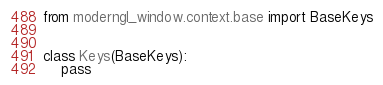<code> <loc_0><loc_0><loc_500><loc_500><_Python_>from moderngl_window.context.base import BaseKeys


class Keys(BaseKeys):
    pass
</code> 